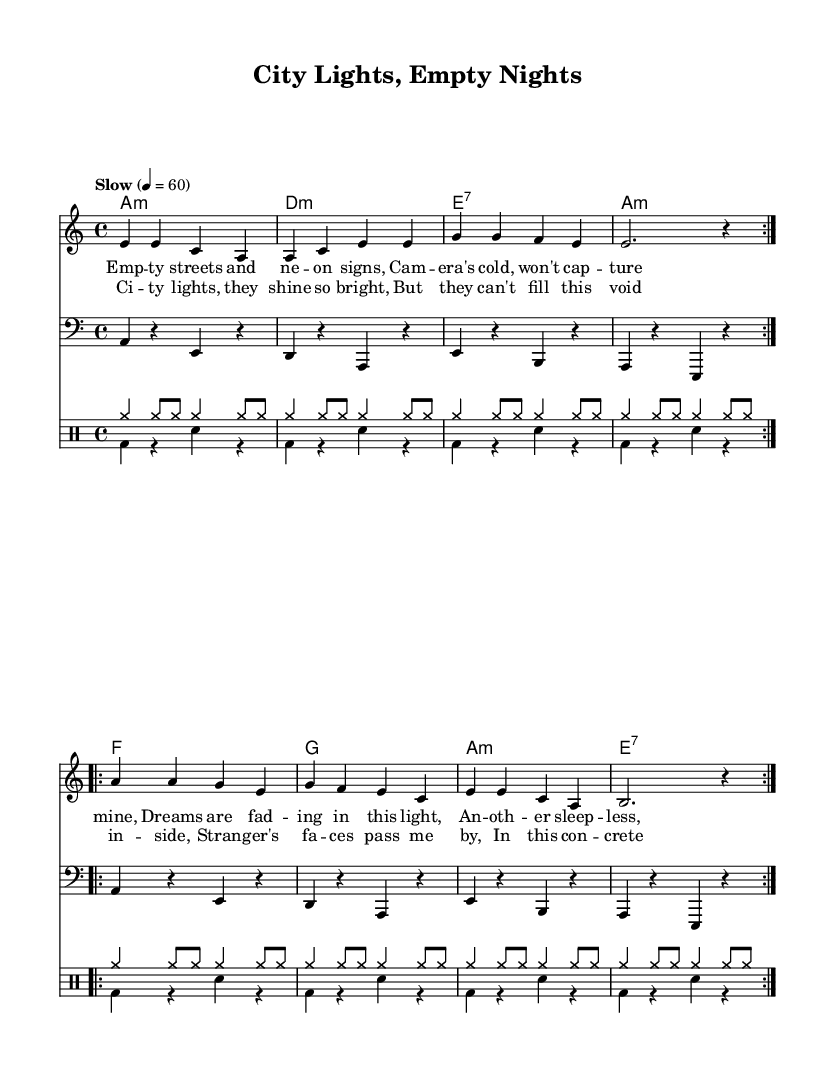What is the key signature of this music? The key signature is A minor, which has no sharps or flats noted. This can be verified by looking at the key signature at the beginning of the sheet music.
Answer: A minor What is the time signature of this music? The time signature is 4/4, indicated at the beginning of the piece. This means there are four beats in each measure.
Answer: 4/4 What is the tempo indication for the piece? The tempo is marked as "Slow" with a metronome marking of 60 beats per minute. This is noted in the tempo section at the beginning.
Answer: Slow What is the first chord in the harmonies section? The first chord in the harmonies section is A minor, as seen when examining the first measure of the chord progression which clearly indicates this chord.
Answer: A minor How many verses does the music contain? The structure of the music shows that there are two repeats of the first section, which indicates that there is effectively one verse, followed by a chorus.
Answer: One What is the main theme expressed in the lyrics? The lyrics convey feelings of loneliness and isolation, particularly in the context of a bustling city life, as illustrated by lines describing empty streets and bright city lights that do not fill the void.
Answer: Loneliness What type of drum pattern is used in the music? The drum pattern consists of a combination of cymbal rhythms in the upper staff, and bass drum and snare in the lower staff, indicative of a typical Blues rhythm section.
Answer: Blues rhythm 